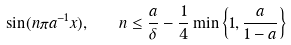<formula> <loc_0><loc_0><loc_500><loc_500>\sin ( n \pi a ^ { - 1 } x ) , \quad n \leq \frac { a } { \delta } - \frac { 1 } { 4 } \min \left \{ 1 , \frac { a } { 1 - a } \right \}</formula> 